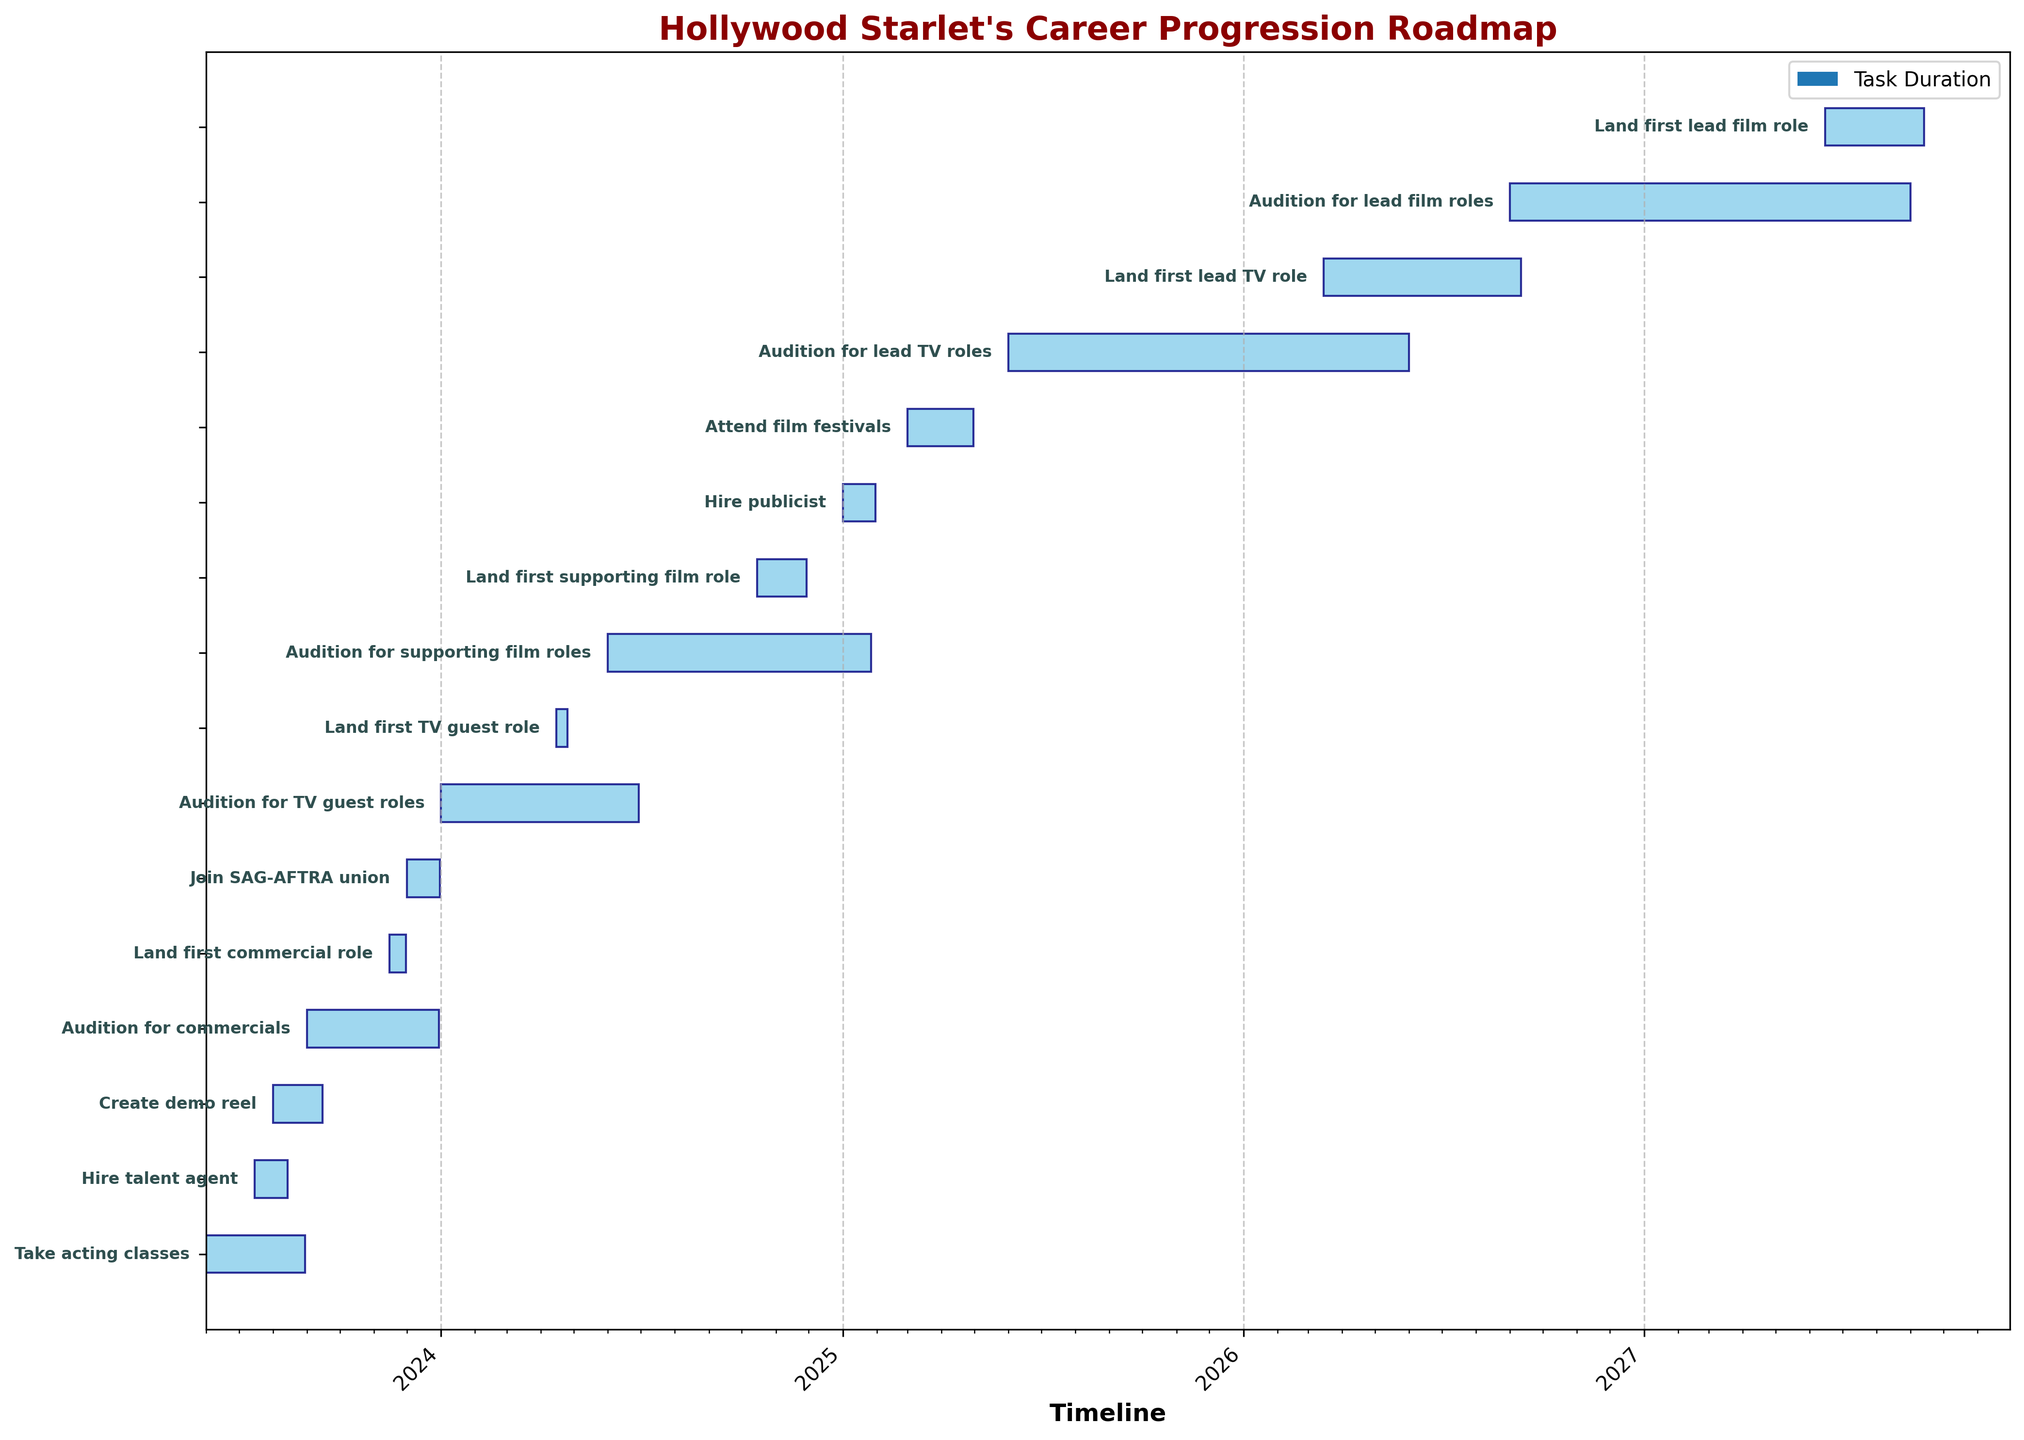What's the title of the Gantt Chart? The title is usually the text that appears at the top of the chart, centered and in a larger font size. It provides a brief description of the chart's content. The title for this Gantt Chart is "Hollywood Starlet's Career Progression Roadmap."
Answer: Hollywood Starlet's Career Progression Roadmap How many tasks are listed on the Gantt Chart? To determine the number of tasks, count the number of horizontal bars, each representing a separate task. There are 15 tasks listed on the chart.
Answer: 15 What is the duration of the first task? The first task is "Take acting classes." The duration bar spans 90 days, which is derived from the dataset and can be observed on the chart.
Answer: 90 days When does the task "Create demo reel" start and end? To find the start date, locate the left end of the corresponding bar on the timeline. For the end date, add the task's duration to the start date. "Create demo reel" starts on 2023-08-01 and, adding 45 days, ends around 2023-09-15.
Answer: Starts on 2023-08-01, ends around 2023-09-15 What is the earliest starting task and the latest ending task? The earliest starting task is the one with the bar beginning at the furthest left point on the timeline, and the latest ending task is the bar ending at the furthest right point on the timeline. The earliest task is "Take acting classes," starting on 2023-06-01, and the latest is "Land first lead film role," ending around 2027-09-15.
Answer: Earliest: Take acting classes; Latest: Land first lead film role How long after "Audition for supporting film roles" starts does "Land first supporting film role" begin? Identify the start date of both tasks and calculate the difference between them. "Audition for supporting film roles" starts on 2024-06-01, and "Land first supporting film role" starts on 2024-10-15. The difference is approximately 136 days.
Answer: 136 days Which task has the longest duration, and what is that duration? Compare the lengths of all the bars by their span from start to end. "Audition for lead TV roles" has the longest duration, spanning 365 days.
Answer: Audition for lead TV roles; 365 days How many tasks are ongoing in the first half of 2024? Identify the tasks that overlap the period from January 1, 2024, to June 30, 2024. Tasks overlapping this period include "Join SAG-AFTRA union," "Audition for TV guest roles," "Land first TV guest role," and "Audition for supporting film roles." There are 4 tasks ongoing.
Answer: 4 tasks What task immediately follows "Audition for lead TV roles"? Look for the task listed right after "Audition for lead TV roles" on the timeline. "Land first lead TV role" immediately follows, spanning March 15, 2026, to September 1, 2026.
Answer: Land first lead TV role 